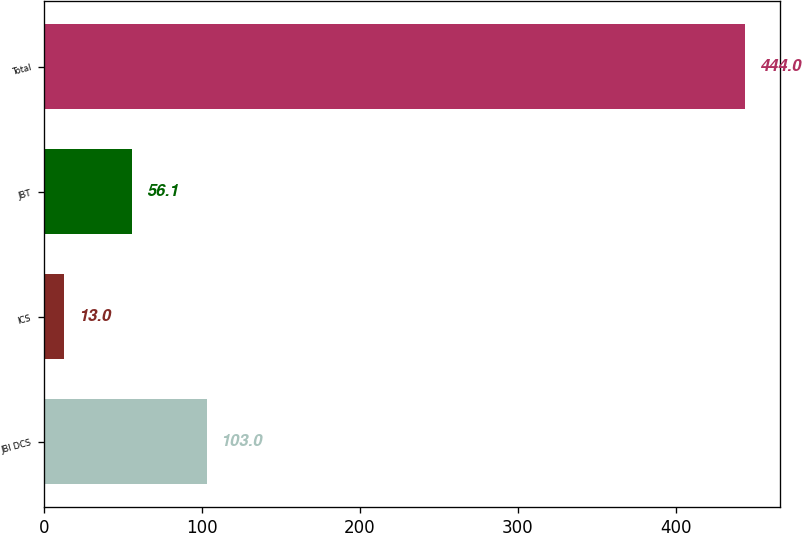Convert chart to OTSL. <chart><loc_0><loc_0><loc_500><loc_500><bar_chart><fcel>JBI DCS<fcel>ICS<fcel>JBT<fcel>Total<nl><fcel>103<fcel>13<fcel>56.1<fcel>444<nl></chart> 